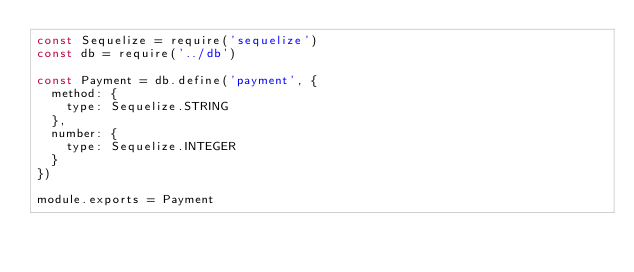<code> <loc_0><loc_0><loc_500><loc_500><_JavaScript_>const Sequelize = require('sequelize')
const db = require('../db')

const Payment = db.define('payment', {
  method: {
    type: Sequelize.STRING
  },
  number: {
    type: Sequelize.INTEGER
  }
})

module.exports = Payment
</code> 